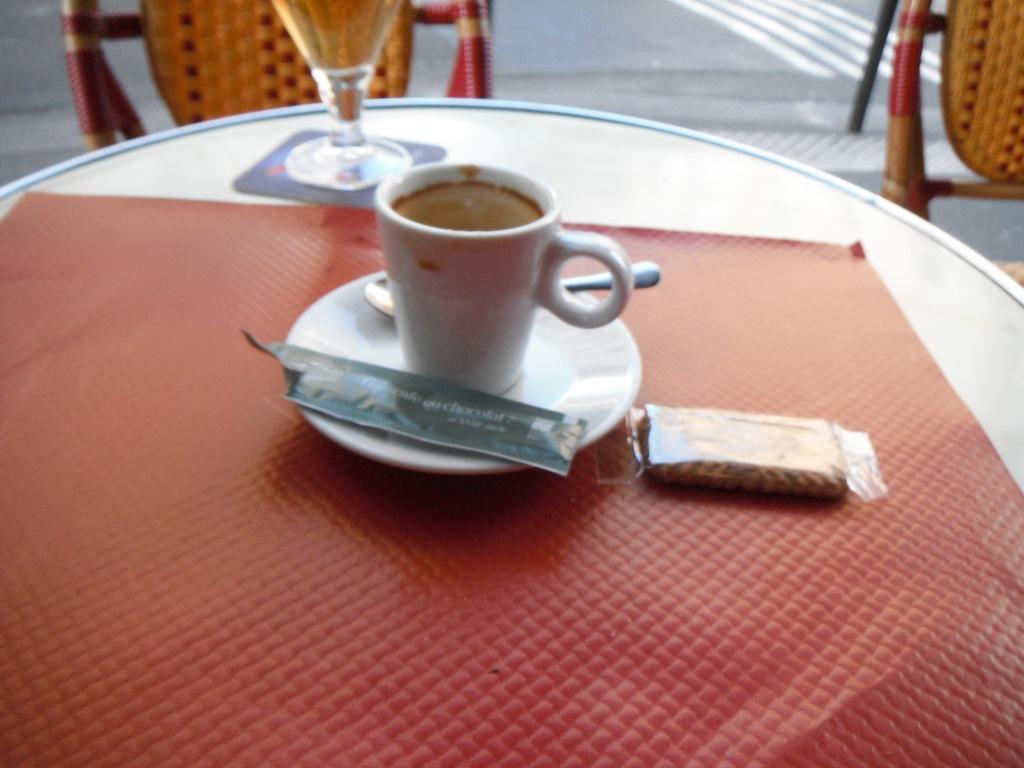Could you give a brief overview of what you see in this image? In this image I can see few chairs and a table. On this table I can see a cup, a spoon, a plate and a packet. 